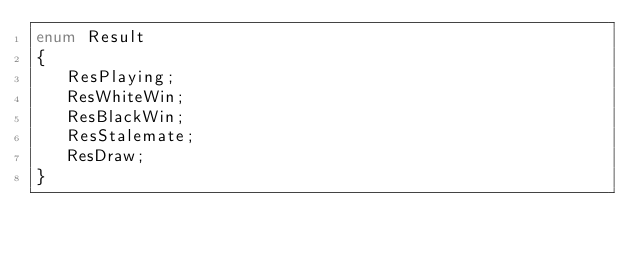<code> <loc_0><loc_0><loc_500><loc_500><_Haxe_>enum Result
{
   ResPlaying;
   ResWhiteWin;
   ResBlackWin;
   ResStalemate;
   ResDraw;
}
</code> 